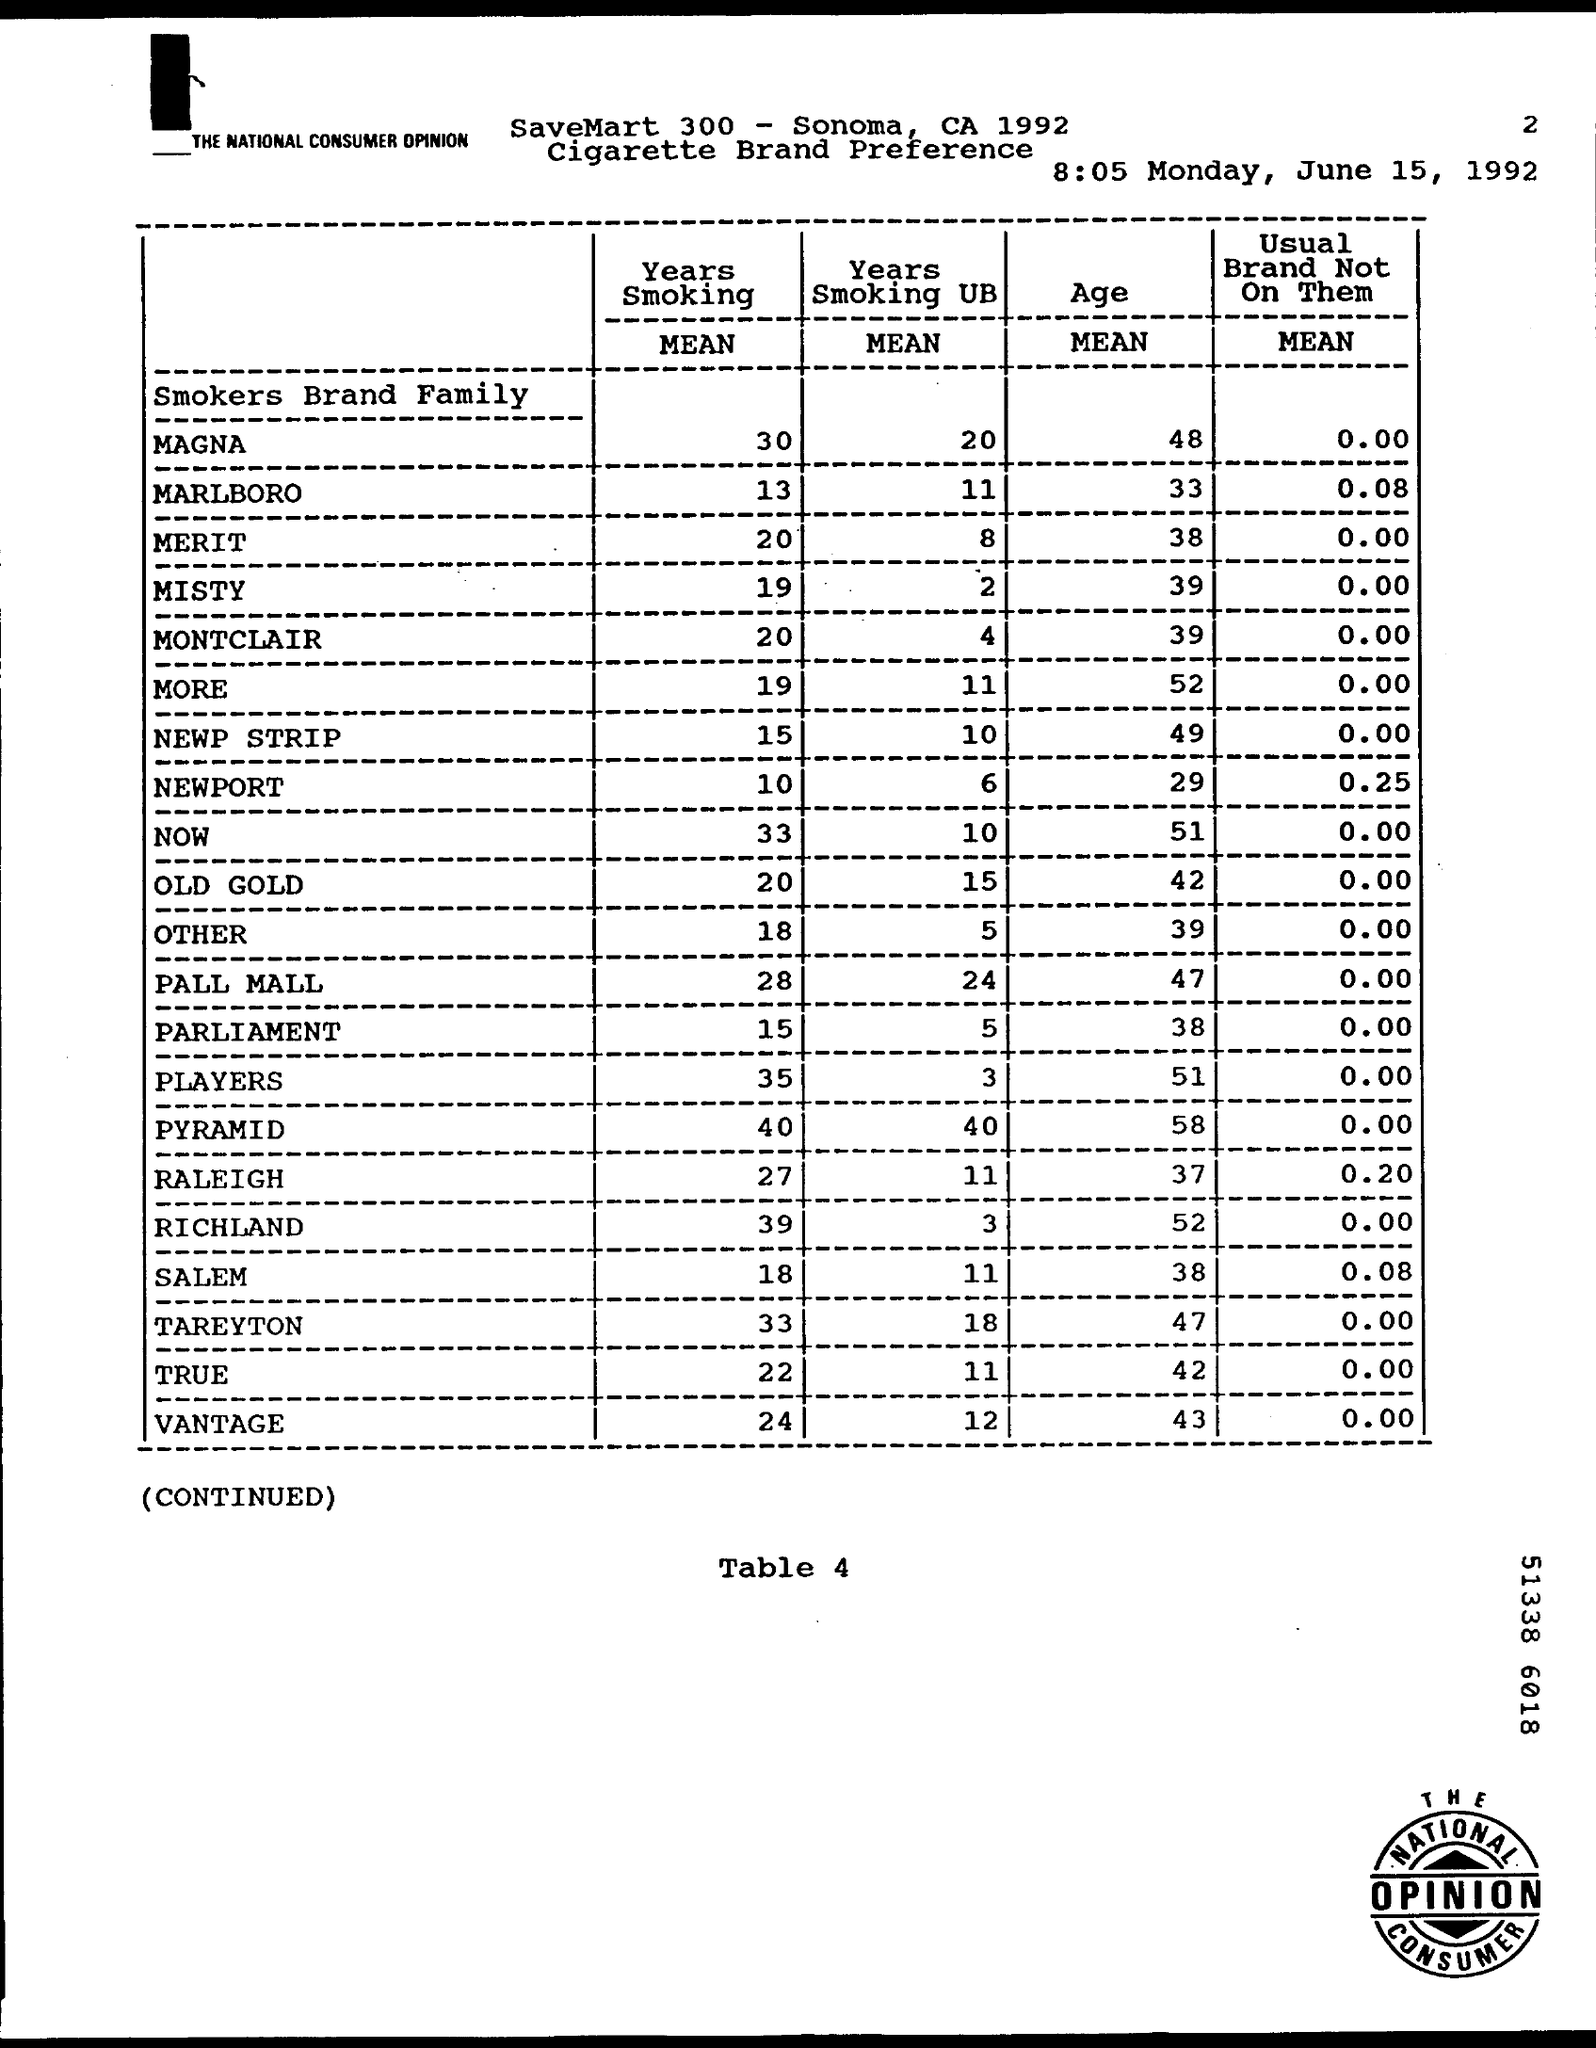Outline some significant characteristics in this image. The mean of years smoking for the brand OLD GOLD is 20 years. The mean age for the brand MARLBORO is 33 years old. The document is dated to be 8:05 Monday, June 15, 1992. What is the table number? It is Table 4. 